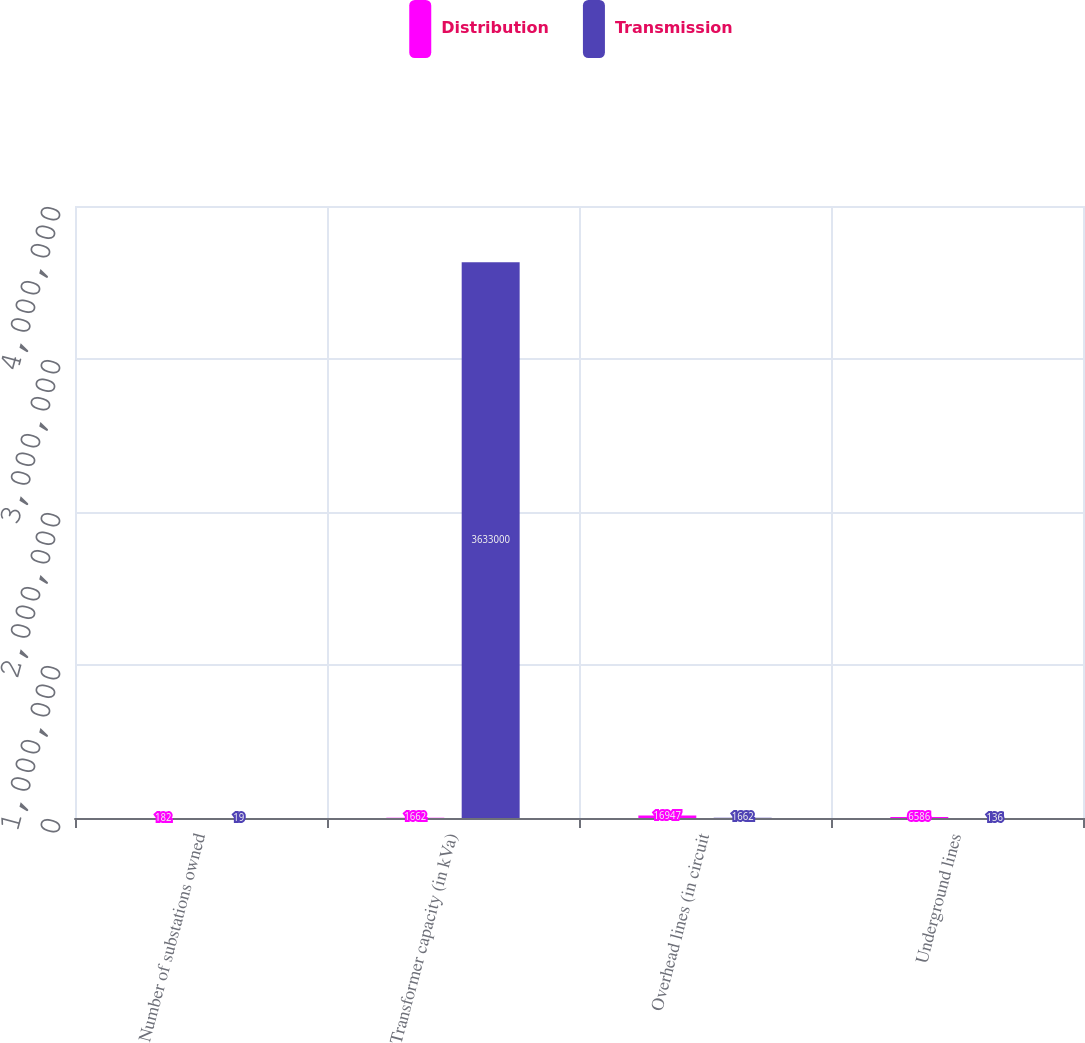Convert chart. <chart><loc_0><loc_0><loc_500><loc_500><stacked_bar_chart><ecel><fcel>Number of substations owned<fcel>Transformer capacity (in kVa)<fcel>Overhead lines (in circuit<fcel>Underground lines<nl><fcel>Distribution<fcel>182<fcel>1662<fcel>16947<fcel>6586<nl><fcel>Transmission<fcel>19<fcel>3.633e+06<fcel>1662<fcel>136<nl></chart> 